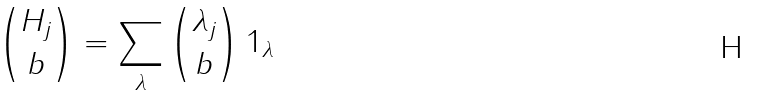Convert formula to latex. <formula><loc_0><loc_0><loc_500><loc_500>\binom { H _ { j } } { b } = \sum _ { \lambda } \binom { \lambda _ { j } } { b } \, 1 _ { \lambda }</formula> 